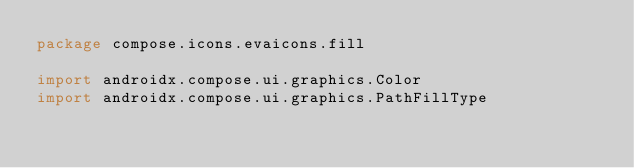<code> <loc_0><loc_0><loc_500><loc_500><_Kotlin_>package compose.icons.evaicons.fill

import androidx.compose.ui.graphics.Color
import androidx.compose.ui.graphics.PathFillType</code> 